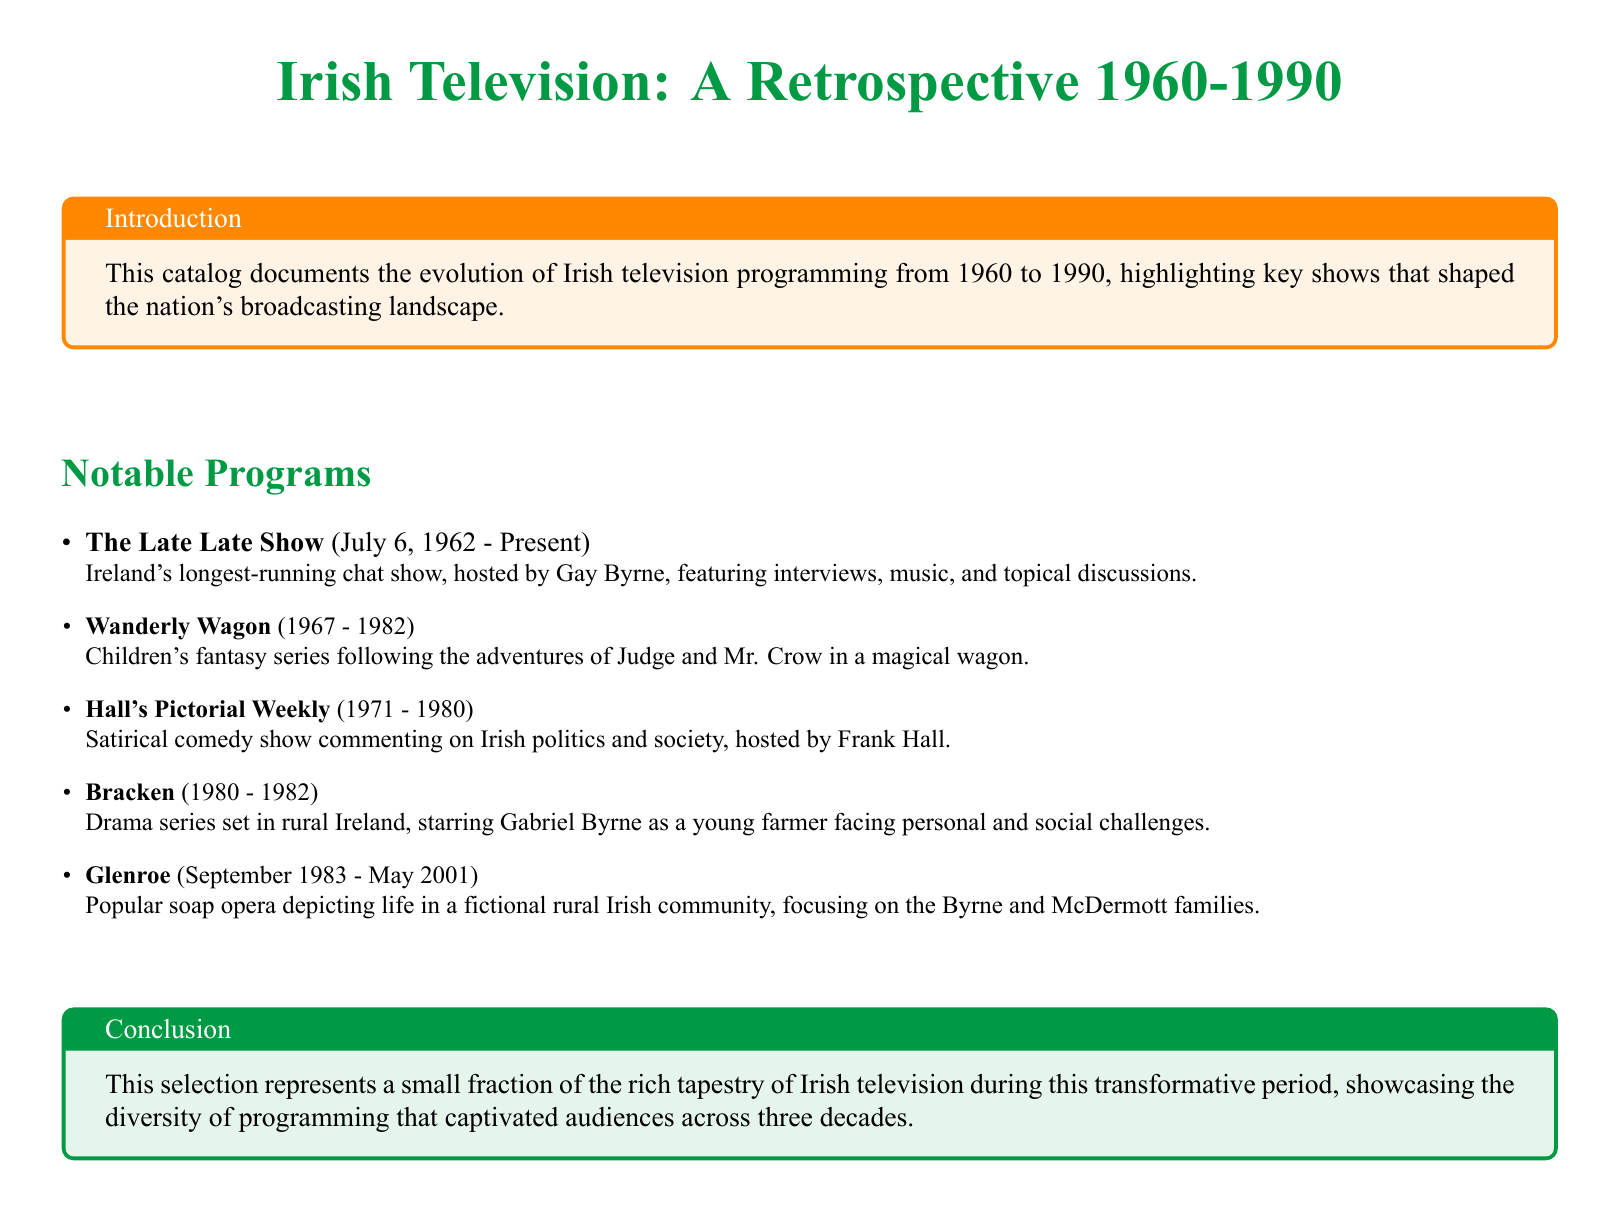What is Ireland's longest-running chat show? The document states that "The Late Late Show" is Ireland's longest-running chat show.
Answer: The Late Late Show Which year did "Wanderly Wagon" first air? The document provides the airdates, stating that "Wanderly Wagon" first aired in 1967.
Answer: 1967 Who hosted "Hall's Pictorial Weekly"? According to the catalog, "Hall's Pictorial Weekly" was hosted by Frank Hall.
Answer: Frank Hall What genre is "Bracken"? The document describes "Bracken" as a drama series.
Answer: Drama In what year did "Glenroe" start airing? The airdates in the document indicate that "Glenroe" began airing in September 1983.
Answer: September 1983 What main theme is present in the soap opera "Glenroe"? The document highlights that "Glenroe" focuses on life in a fictional rural Irish community.
Answer: Life in a fictional rural Irish community How long did "Hall's Pictorial Weekly" run? The document lists the airdates for "Hall's Pictorial Weekly" from 1971 to 1980, indicating it ran for 9 years.
Answer: 9 years Which program features a magical wagon? The catalog specifically mentions that "Wanderly Wagon" follows the adventures in a magical wagon.
Answer: Wanderly Wagon What period does the catalog cover? The introduction notes that the catalog documents Irish television programming from 1960 to 1990.
Answer: 1960-1990 